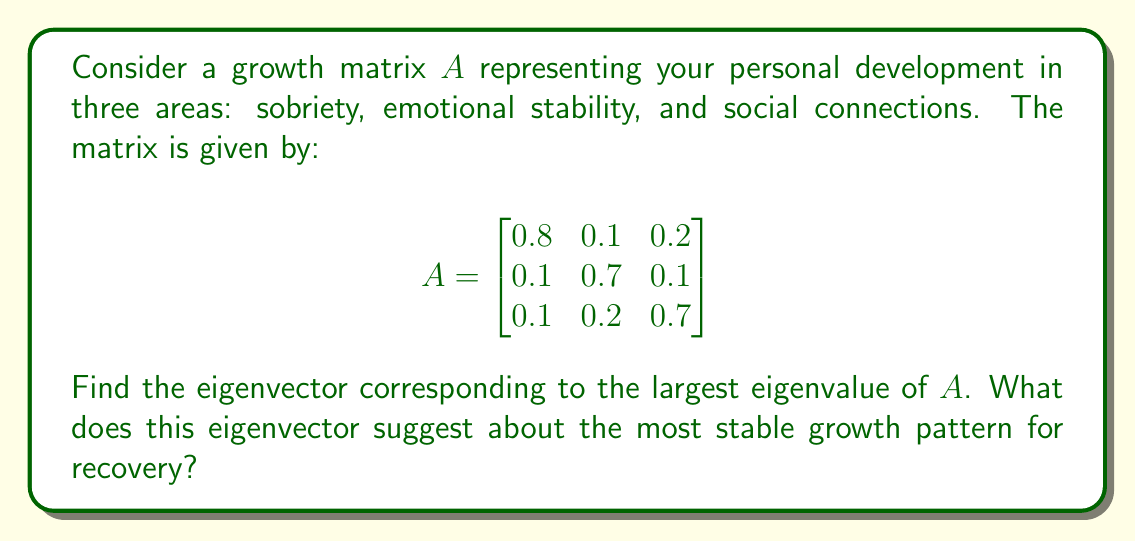Help me with this question. 1. First, we need to find the eigenvalues of matrix $A$. The characteristic equation is:

   $\det(A - \lambda I) = 0$

   $\begin{vmatrix}
   0.8-\lambda & 0.1 & 0.2 \\
   0.1 & 0.7-\lambda & 0.1 \\
   0.1 & 0.2 & 0.7-\lambda
   \end{vmatrix} = 0$

2. Expanding this determinant:

   $(\lambda-0.8)(\lambda-0.7)^2 - 0.02(\lambda-0.7) - 0.05 = 0$

3. Solving this equation (which can be done using a calculator or computer algebra system) gives us the eigenvalues:

   $\lambda_1 \approx 1$, $\lambda_2 \approx 0.6$, $\lambda_3 \approx 0.6$

4. The largest eigenvalue is $\lambda_1 \approx 1$.

5. To find the corresponding eigenvector, we solve $(A - \lambda_1 I)v = 0$:

   $$\begin{bmatrix}
   -0.2 & 0.1 & 0.2 \\
   0.1 & -0.3 & 0.1 \\
   0.1 & 0.2 & -0.3
   \end{bmatrix} \begin{bmatrix} v_1 \\ v_2 \\ v_3 \end{bmatrix} = \begin{bmatrix} 0 \\ 0 \\ 0 \end{bmatrix}$$

6. Solving this system (again, using computational tools), we get the eigenvector:

   $v \approx (0.5774, 0.5774, 0.5774)$

7. Normalizing this vector, we get:

   $v \approx (0.5774, 0.5774, 0.5774)$

This eigenvector suggests that the most stable growth pattern involves equal emphasis on all three areas: sobriety, emotional stability, and social connections. Each component has approximately the same value, indicating that balanced growth in all areas is key to long-term recovery and stability.
Answer: $(0.5774, 0.5774, 0.5774)$ 